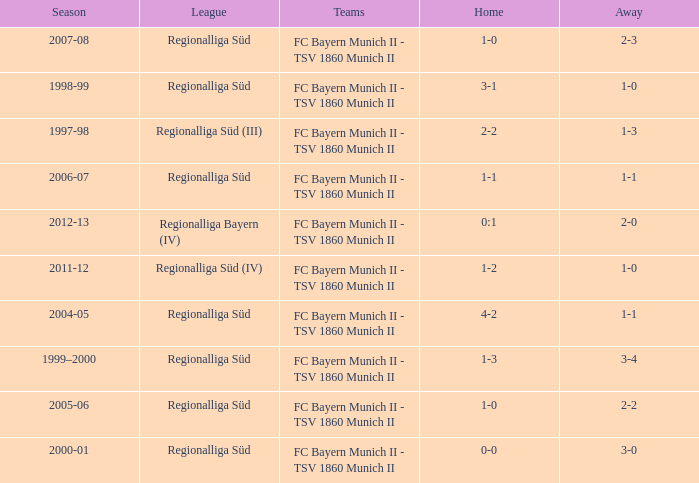Which season has the regionalliga süd (iii) league? 1997-98. 